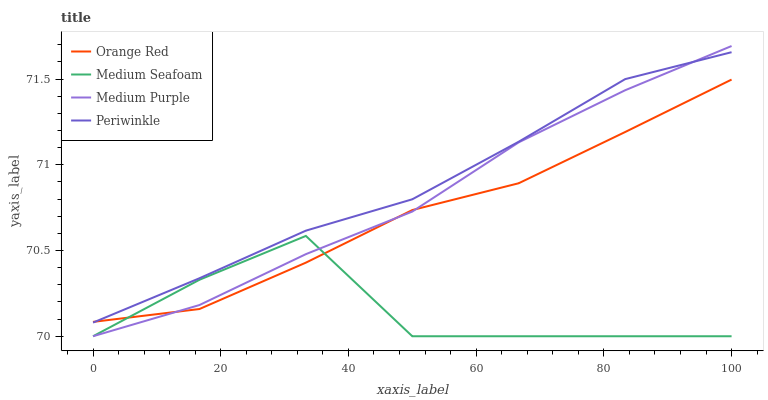Does Orange Red have the minimum area under the curve?
Answer yes or no. No. Does Orange Red have the maximum area under the curve?
Answer yes or no. No. Is Periwinkle the smoothest?
Answer yes or no. No. Is Periwinkle the roughest?
Answer yes or no. No. Does Periwinkle have the lowest value?
Answer yes or no. No. Does Periwinkle have the highest value?
Answer yes or no. No. Is Medium Seafoam less than Periwinkle?
Answer yes or no. Yes. Is Periwinkle greater than Medium Seafoam?
Answer yes or no. Yes. Does Medium Seafoam intersect Periwinkle?
Answer yes or no. No. 